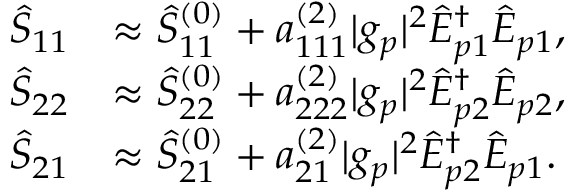<formula> <loc_0><loc_0><loc_500><loc_500>\begin{array} { r l } { \hat { S } _ { 1 1 } } & { \approx \hat { S } _ { 1 1 } ^ { ( 0 ) } + a _ { 1 1 1 } ^ { ( 2 ) } | g _ { p } | ^ { 2 } \hat { E } _ { p 1 } ^ { \dagger } \hat { E } _ { p 1 } , } \\ { \hat { S } _ { 2 2 } } & { \approx \hat { S } _ { 2 2 } ^ { ( 0 ) } + a _ { 2 2 2 } ^ { ( 2 ) } | g _ { p } | ^ { 2 } \hat { E } _ { p 2 } ^ { \dagger } \hat { E } _ { p 2 } , } \\ { \hat { S } _ { 2 1 } } & { \approx \hat { S } _ { 2 1 } ^ { ( 0 ) } + a _ { 2 1 } ^ { ( 2 ) } | g _ { p } | ^ { 2 } \hat { E } _ { p 2 } ^ { \dagger } \hat { E } _ { p 1 } . } \end{array}</formula> 